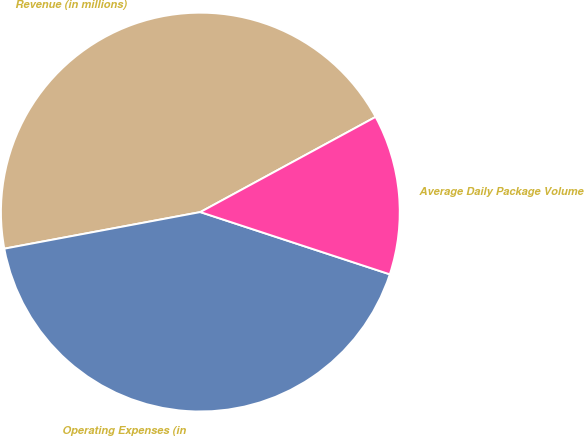Convert chart. <chart><loc_0><loc_0><loc_500><loc_500><pie_chart><fcel>Revenue (in millions)<fcel>Operating Expenses (in<fcel>Average Daily Package Volume<nl><fcel>45.02%<fcel>42.01%<fcel>12.97%<nl></chart> 